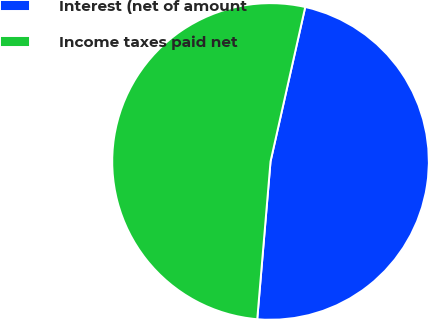<chart> <loc_0><loc_0><loc_500><loc_500><pie_chart><fcel>Interest (net of amount<fcel>Income taxes paid net<nl><fcel>47.82%<fcel>52.18%<nl></chart> 